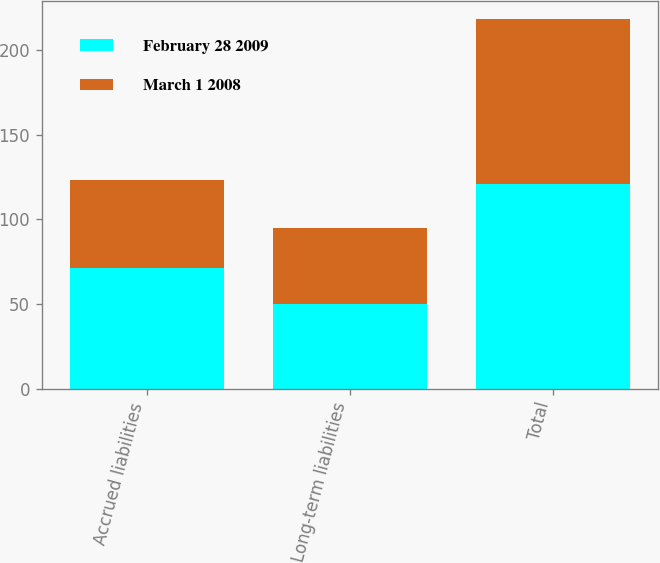<chart> <loc_0><loc_0><loc_500><loc_500><stacked_bar_chart><ecel><fcel>Accrued liabilities<fcel>Long-term liabilities<fcel>Total<nl><fcel>February 28 2009<fcel>71<fcel>50<fcel>121<nl><fcel>March 1 2008<fcel>52<fcel>45<fcel>97<nl></chart> 